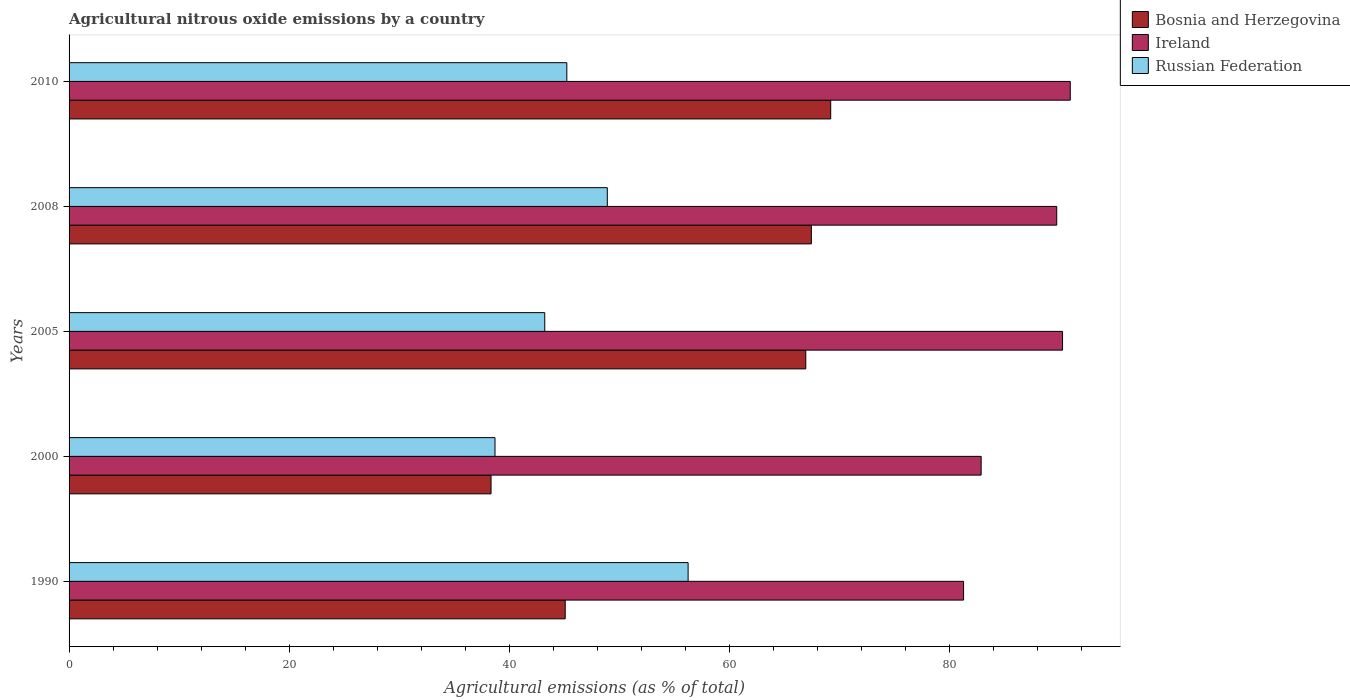How many different coloured bars are there?
Provide a succinct answer. 3. How many groups of bars are there?
Your answer should be very brief. 5. Are the number of bars per tick equal to the number of legend labels?
Provide a short and direct response. Yes. How many bars are there on the 5th tick from the bottom?
Offer a terse response. 3. What is the label of the 3rd group of bars from the top?
Offer a very short reply. 2005. What is the amount of agricultural nitrous oxide emitted in Ireland in 2005?
Provide a short and direct response. 90.31. Across all years, what is the maximum amount of agricultural nitrous oxide emitted in Ireland?
Offer a terse response. 91.01. Across all years, what is the minimum amount of agricultural nitrous oxide emitted in Bosnia and Herzegovina?
Provide a short and direct response. 38.36. What is the total amount of agricultural nitrous oxide emitted in Russian Federation in the graph?
Keep it short and to the point. 232.4. What is the difference between the amount of agricultural nitrous oxide emitted in Russian Federation in 2000 and that in 2005?
Make the answer very short. -4.52. What is the difference between the amount of agricultural nitrous oxide emitted in Russian Federation in 2010 and the amount of agricultural nitrous oxide emitted in Bosnia and Herzegovina in 2005?
Your response must be concise. -21.72. What is the average amount of agricultural nitrous oxide emitted in Ireland per year?
Keep it short and to the point. 87.06. In the year 2005, what is the difference between the amount of agricultural nitrous oxide emitted in Russian Federation and amount of agricultural nitrous oxide emitted in Ireland?
Give a very brief answer. -47.07. In how many years, is the amount of agricultural nitrous oxide emitted in Russian Federation greater than 28 %?
Make the answer very short. 5. What is the ratio of the amount of agricultural nitrous oxide emitted in Russian Federation in 2000 to that in 2010?
Your answer should be compact. 0.86. What is the difference between the highest and the second highest amount of agricultural nitrous oxide emitted in Bosnia and Herzegovina?
Make the answer very short. 1.76. What is the difference between the highest and the lowest amount of agricultural nitrous oxide emitted in Ireland?
Provide a short and direct response. 9.7. In how many years, is the amount of agricultural nitrous oxide emitted in Bosnia and Herzegovina greater than the average amount of agricultural nitrous oxide emitted in Bosnia and Herzegovina taken over all years?
Your answer should be very brief. 3. Is the sum of the amount of agricultural nitrous oxide emitted in Bosnia and Herzegovina in 1990 and 2005 greater than the maximum amount of agricultural nitrous oxide emitted in Ireland across all years?
Your answer should be compact. Yes. What does the 2nd bar from the top in 2005 represents?
Your answer should be very brief. Ireland. What does the 2nd bar from the bottom in 2008 represents?
Your answer should be very brief. Ireland. Is it the case that in every year, the sum of the amount of agricultural nitrous oxide emitted in Ireland and amount of agricultural nitrous oxide emitted in Bosnia and Herzegovina is greater than the amount of agricultural nitrous oxide emitted in Russian Federation?
Your response must be concise. Yes. How many bars are there?
Provide a succinct answer. 15. Are all the bars in the graph horizontal?
Keep it short and to the point. Yes. How many years are there in the graph?
Make the answer very short. 5. Are the values on the major ticks of X-axis written in scientific E-notation?
Ensure brevity in your answer.  No. Does the graph contain any zero values?
Offer a very short reply. No. Where does the legend appear in the graph?
Ensure brevity in your answer.  Top right. What is the title of the graph?
Provide a short and direct response. Agricultural nitrous oxide emissions by a country. Does "Congo (Democratic)" appear as one of the legend labels in the graph?
Ensure brevity in your answer.  No. What is the label or title of the X-axis?
Make the answer very short. Agricultural emissions (as % of total). What is the Agricultural emissions (as % of total) of Bosnia and Herzegovina in 1990?
Give a very brief answer. 45.1. What is the Agricultural emissions (as % of total) in Ireland in 1990?
Provide a short and direct response. 81.31. What is the Agricultural emissions (as % of total) in Russian Federation in 1990?
Give a very brief answer. 56.27. What is the Agricultural emissions (as % of total) in Bosnia and Herzegovina in 2000?
Provide a succinct answer. 38.36. What is the Agricultural emissions (as % of total) in Ireland in 2000?
Give a very brief answer. 82.91. What is the Agricultural emissions (as % of total) of Russian Federation in 2000?
Give a very brief answer. 38.72. What is the Agricultural emissions (as % of total) of Bosnia and Herzegovina in 2005?
Give a very brief answer. 66.97. What is the Agricultural emissions (as % of total) in Ireland in 2005?
Your answer should be very brief. 90.31. What is the Agricultural emissions (as % of total) of Russian Federation in 2005?
Keep it short and to the point. 43.24. What is the Agricultural emissions (as % of total) in Bosnia and Herzegovina in 2008?
Your answer should be very brief. 67.47. What is the Agricultural emissions (as % of total) in Ireland in 2008?
Offer a very short reply. 89.78. What is the Agricultural emissions (as % of total) of Russian Federation in 2008?
Offer a very short reply. 48.93. What is the Agricultural emissions (as % of total) of Bosnia and Herzegovina in 2010?
Your answer should be very brief. 69.23. What is the Agricultural emissions (as % of total) in Ireland in 2010?
Your response must be concise. 91.01. What is the Agricultural emissions (as % of total) of Russian Federation in 2010?
Give a very brief answer. 45.25. Across all years, what is the maximum Agricultural emissions (as % of total) of Bosnia and Herzegovina?
Give a very brief answer. 69.23. Across all years, what is the maximum Agricultural emissions (as % of total) in Ireland?
Provide a short and direct response. 91.01. Across all years, what is the maximum Agricultural emissions (as % of total) of Russian Federation?
Give a very brief answer. 56.27. Across all years, what is the minimum Agricultural emissions (as % of total) in Bosnia and Herzegovina?
Your response must be concise. 38.36. Across all years, what is the minimum Agricultural emissions (as % of total) of Ireland?
Offer a terse response. 81.31. Across all years, what is the minimum Agricultural emissions (as % of total) of Russian Federation?
Your answer should be very brief. 38.72. What is the total Agricultural emissions (as % of total) of Bosnia and Herzegovina in the graph?
Provide a short and direct response. 287.13. What is the total Agricultural emissions (as % of total) of Ireland in the graph?
Keep it short and to the point. 435.31. What is the total Agricultural emissions (as % of total) of Russian Federation in the graph?
Your response must be concise. 232.4. What is the difference between the Agricultural emissions (as % of total) in Bosnia and Herzegovina in 1990 and that in 2000?
Provide a short and direct response. 6.74. What is the difference between the Agricultural emissions (as % of total) in Ireland in 1990 and that in 2000?
Make the answer very short. -1.6. What is the difference between the Agricultural emissions (as % of total) of Russian Federation in 1990 and that in 2000?
Offer a very short reply. 17.55. What is the difference between the Agricultural emissions (as % of total) in Bosnia and Herzegovina in 1990 and that in 2005?
Your answer should be very brief. -21.87. What is the difference between the Agricultural emissions (as % of total) in Ireland in 1990 and that in 2005?
Offer a terse response. -9. What is the difference between the Agricultural emissions (as % of total) of Russian Federation in 1990 and that in 2005?
Offer a terse response. 13.03. What is the difference between the Agricultural emissions (as % of total) in Bosnia and Herzegovina in 1990 and that in 2008?
Keep it short and to the point. -22.37. What is the difference between the Agricultural emissions (as % of total) of Ireland in 1990 and that in 2008?
Give a very brief answer. -8.47. What is the difference between the Agricultural emissions (as % of total) of Russian Federation in 1990 and that in 2008?
Ensure brevity in your answer.  7.34. What is the difference between the Agricultural emissions (as % of total) of Bosnia and Herzegovina in 1990 and that in 2010?
Your answer should be very brief. -24.13. What is the difference between the Agricultural emissions (as % of total) in Ireland in 1990 and that in 2010?
Provide a succinct answer. -9.7. What is the difference between the Agricultural emissions (as % of total) of Russian Federation in 1990 and that in 2010?
Provide a succinct answer. 11.02. What is the difference between the Agricultural emissions (as % of total) in Bosnia and Herzegovina in 2000 and that in 2005?
Make the answer very short. -28.61. What is the difference between the Agricultural emissions (as % of total) in Ireland in 2000 and that in 2005?
Ensure brevity in your answer.  -7.4. What is the difference between the Agricultural emissions (as % of total) of Russian Federation in 2000 and that in 2005?
Provide a short and direct response. -4.52. What is the difference between the Agricultural emissions (as % of total) of Bosnia and Herzegovina in 2000 and that in 2008?
Provide a short and direct response. -29.12. What is the difference between the Agricultural emissions (as % of total) of Ireland in 2000 and that in 2008?
Your answer should be compact. -6.87. What is the difference between the Agricultural emissions (as % of total) in Russian Federation in 2000 and that in 2008?
Give a very brief answer. -10.21. What is the difference between the Agricultural emissions (as % of total) of Bosnia and Herzegovina in 2000 and that in 2010?
Your answer should be very brief. -30.88. What is the difference between the Agricultural emissions (as % of total) in Ireland in 2000 and that in 2010?
Offer a terse response. -8.1. What is the difference between the Agricultural emissions (as % of total) of Russian Federation in 2000 and that in 2010?
Your answer should be compact. -6.53. What is the difference between the Agricultural emissions (as % of total) of Bosnia and Herzegovina in 2005 and that in 2008?
Offer a terse response. -0.51. What is the difference between the Agricultural emissions (as % of total) in Ireland in 2005 and that in 2008?
Provide a short and direct response. 0.53. What is the difference between the Agricultural emissions (as % of total) in Russian Federation in 2005 and that in 2008?
Provide a succinct answer. -5.69. What is the difference between the Agricultural emissions (as % of total) of Bosnia and Herzegovina in 2005 and that in 2010?
Your answer should be compact. -2.27. What is the difference between the Agricultural emissions (as % of total) in Ireland in 2005 and that in 2010?
Ensure brevity in your answer.  -0.7. What is the difference between the Agricultural emissions (as % of total) in Russian Federation in 2005 and that in 2010?
Give a very brief answer. -2.01. What is the difference between the Agricultural emissions (as % of total) of Bosnia and Herzegovina in 2008 and that in 2010?
Provide a succinct answer. -1.76. What is the difference between the Agricultural emissions (as % of total) of Ireland in 2008 and that in 2010?
Offer a terse response. -1.23. What is the difference between the Agricultural emissions (as % of total) of Russian Federation in 2008 and that in 2010?
Keep it short and to the point. 3.68. What is the difference between the Agricultural emissions (as % of total) of Bosnia and Herzegovina in 1990 and the Agricultural emissions (as % of total) of Ireland in 2000?
Your response must be concise. -37.81. What is the difference between the Agricultural emissions (as % of total) of Bosnia and Herzegovina in 1990 and the Agricultural emissions (as % of total) of Russian Federation in 2000?
Offer a very short reply. 6.38. What is the difference between the Agricultural emissions (as % of total) of Ireland in 1990 and the Agricultural emissions (as % of total) of Russian Federation in 2000?
Provide a succinct answer. 42.59. What is the difference between the Agricultural emissions (as % of total) of Bosnia and Herzegovina in 1990 and the Agricultural emissions (as % of total) of Ireland in 2005?
Provide a succinct answer. -45.21. What is the difference between the Agricultural emissions (as % of total) in Bosnia and Herzegovina in 1990 and the Agricultural emissions (as % of total) in Russian Federation in 2005?
Your answer should be compact. 1.86. What is the difference between the Agricultural emissions (as % of total) in Ireland in 1990 and the Agricultural emissions (as % of total) in Russian Federation in 2005?
Provide a succinct answer. 38.07. What is the difference between the Agricultural emissions (as % of total) of Bosnia and Herzegovina in 1990 and the Agricultural emissions (as % of total) of Ireland in 2008?
Give a very brief answer. -44.68. What is the difference between the Agricultural emissions (as % of total) of Bosnia and Herzegovina in 1990 and the Agricultural emissions (as % of total) of Russian Federation in 2008?
Provide a succinct answer. -3.83. What is the difference between the Agricultural emissions (as % of total) of Ireland in 1990 and the Agricultural emissions (as % of total) of Russian Federation in 2008?
Offer a terse response. 32.38. What is the difference between the Agricultural emissions (as % of total) in Bosnia and Herzegovina in 1990 and the Agricultural emissions (as % of total) in Ireland in 2010?
Your answer should be compact. -45.91. What is the difference between the Agricultural emissions (as % of total) in Bosnia and Herzegovina in 1990 and the Agricultural emissions (as % of total) in Russian Federation in 2010?
Your answer should be compact. -0.15. What is the difference between the Agricultural emissions (as % of total) of Ireland in 1990 and the Agricultural emissions (as % of total) of Russian Federation in 2010?
Your response must be concise. 36.07. What is the difference between the Agricultural emissions (as % of total) in Bosnia and Herzegovina in 2000 and the Agricultural emissions (as % of total) in Ireland in 2005?
Offer a very short reply. -51.95. What is the difference between the Agricultural emissions (as % of total) of Bosnia and Herzegovina in 2000 and the Agricultural emissions (as % of total) of Russian Federation in 2005?
Your answer should be very brief. -4.88. What is the difference between the Agricultural emissions (as % of total) of Ireland in 2000 and the Agricultural emissions (as % of total) of Russian Federation in 2005?
Offer a terse response. 39.67. What is the difference between the Agricultural emissions (as % of total) in Bosnia and Herzegovina in 2000 and the Agricultural emissions (as % of total) in Ireland in 2008?
Your response must be concise. -51.42. What is the difference between the Agricultural emissions (as % of total) of Bosnia and Herzegovina in 2000 and the Agricultural emissions (as % of total) of Russian Federation in 2008?
Offer a terse response. -10.57. What is the difference between the Agricultural emissions (as % of total) of Ireland in 2000 and the Agricultural emissions (as % of total) of Russian Federation in 2008?
Provide a succinct answer. 33.98. What is the difference between the Agricultural emissions (as % of total) of Bosnia and Herzegovina in 2000 and the Agricultural emissions (as % of total) of Ireland in 2010?
Provide a short and direct response. -52.65. What is the difference between the Agricultural emissions (as % of total) in Bosnia and Herzegovina in 2000 and the Agricultural emissions (as % of total) in Russian Federation in 2010?
Give a very brief answer. -6.89. What is the difference between the Agricultural emissions (as % of total) in Ireland in 2000 and the Agricultural emissions (as % of total) in Russian Federation in 2010?
Keep it short and to the point. 37.66. What is the difference between the Agricultural emissions (as % of total) in Bosnia and Herzegovina in 2005 and the Agricultural emissions (as % of total) in Ireland in 2008?
Give a very brief answer. -22.81. What is the difference between the Agricultural emissions (as % of total) of Bosnia and Herzegovina in 2005 and the Agricultural emissions (as % of total) of Russian Federation in 2008?
Give a very brief answer. 18.04. What is the difference between the Agricultural emissions (as % of total) in Ireland in 2005 and the Agricultural emissions (as % of total) in Russian Federation in 2008?
Keep it short and to the point. 41.38. What is the difference between the Agricultural emissions (as % of total) in Bosnia and Herzegovina in 2005 and the Agricultural emissions (as % of total) in Ireland in 2010?
Ensure brevity in your answer.  -24.04. What is the difference between the Agricultural emissions (as % of total) of Bosnia and Herzegovina in 2005 and the Agricultural emissions (as % of total) of Russian Federation in 2010?
Provide a short and direct response. 21.72. What is the difference between the Agricultural emissions (as % of total) in Ireland in 2005 and the Agricultural emissions (as % of total) in Russian Federation in 2010?
Keep it short and to the point. 45.06. What is the difference between the Agricultural emissions (as % of total) in Bosnia and Herzegovina in 2008 and the Agricultural emissions (as % of total) in Ireland in 2010?
Your response must be concise. -23.53. What is the difference between the Agricultural emissions (as % of total) of Bosnia and Herzegovina in 2008 and the Agricultural emissions (as % of total) of Russian Federation in 2010?
Provide a succinct answer. 22.23. What is the difference between the Agricultural emissions (as % of total) of Ireland in 2008 and the Agricultural emissions (as % of total) of Russian Federation in 2010?
Provide a short and direct response. 44.53. What is the average Agricultural emissions (as % of total) in Bosnia and Herzegovina per year?
Provide a succinct answer. 57.43. What is the average Agricultural emissions (as % of total) of Ireland per year?
Offer a terse response. 87.06. What is the average Agricultural emissions (as % of total) in Russian Federation per year?
Provide a succinct answer. 46.48. In the year 1990, what is the difference between the Agricultural emissions (as % of total) in Bosnia and Herzegovina and Agricultural emissions (as % of total) in Ireland?
Ensure brevity in your answer.  -36.21. In the year 1990, what is the difference between the Agricultural emissions (as % of total) of Bosnia and Herzegovina and Agricultural emissions (as % of total) of Russian Federation?
Your answer should be compact. -11.17. In the year 1990, what is the difference between the Agricultural emissions (as % of total) in Ireland and Agricultural emissions (as % of total) in Russian Federation?
Your answer should be very brief. 25.04. In the year 2000, what is the difference between the Agricultural emissions (as % of total) of Bosnia and Herzegovina and Agricultural emissions (as % of total) of Ireland?
Make the answer very short. -44.55. In the year 2000, what is the difference between the Agricultural emissions (as % of total) of Bosnia and Herzegovina and Agricultural emissions (as % of total) of Russian Federation?
Make the answer very short. -0.36. In the year 2000, what is the difference between the Agricultural emissions (as % of total) in Ireland and Agricultural emissions (as % of total) in Russian Federation?
Your answer should be very brief. 44.19. In the year 2005, what is the difference between the Agricultural emissions (as % of total) in Bosnia and Herzegovina and Agricultural emissions (as % of total) in Ireland?
Your response must be concise. -23.34. In the year 2005, what is the difference between the Agricultural emissions (as % of total) of Bosnia and Herzegovina and Agricultural emissions (as % of total) of Russian Federation?
Offer a terse response. 23.73. In the year 2005, what is the difference between the Agricultural emissions (as % of total) in Ireland and Agricultural emissions (as % of total) in Russian Federation?
Ensure brevity in your answer.  47.07. In the year 2008, what is the difference between the Agricultural emissions (as % of total) of Bosnia and Herzegovina and Agricultural emissions (as % of total) of Ireland?
Provide a short and direct response. -22.31. In the year 2008, what is the difference between the Agricultural emissions (as % of total) of Bosnia and Herzegovina and Agricultural emissions (as % of total) of Russian Federation?
Give a very brief answer. 18.55. In the year 2008, what is the difference between the Agricultural emissions (as % of total) of Ireland and Agricultural emissions (as % of total) of Russian Federation?
Ensure brevity in your answer.  40.85. In the year 2010, what is the difference between the Agricultural emissions (as % of total) in Bosnia and Herzegovina and Agricultural emissions (as % of total) in Ireland?
Offer a very short reply. -21.78. In the year 2010, what is the difference between the Agricultural emissions (as % of total) in Bosnia and Herzegovina and Agricultural emissions (as % of total) in Russian Federation?
Offer a very short reply. 23.99. In the year 2010, what is the difference between the Agricultural emissions (as % of total) in Ireland and Agricultural emissions (as % of total) in Russian Federation?
Your answer should be very brief. 45.76. What is the ratio of the Agricultural emissions (as % of total) in Bosnia and Herzegovina in 1990 to that in 2000?
Your answer should be compact. 1.18. What is the ratio of the Agricultural emissions (as % of total) of Ireland in 1990 to that in 2000?
Offer a terse response. 0.98. What is the ratio of the Agricultural emissions (as % of total) in Russian Federation in 1990 to that in 2000?
Offer a terse response. 1.45. What is the ratio of the Agricultural emissions (as % of total) in Bosnia and Herzegovina in 1990 to that in 2005?
Make the answer very short. 0.67. What is the ratio of the Agricultural emissions (as % of total) in Ireland in 1990 to that in 2005?
Provide a short and direct response. 0.9. What is the ratio of the Agricultural emissions (as % of total) of Russian Federation in 1990 to that in 2005?
Provide a succinct answer. 1.3. What is the ratio of the Agricultural emissions (as % of total) of Bosnia and Herzegovina in 1990 to that in 2008?
Provide a succinct answer. 0.67. What is the ratio of the Agricultural emissions (as % of total) in Ireland in 1990 to that in 2008?
Keep it short and to the point. 0.91. What is the ratio of the Agricultural emissions (as % of total) in Russian Federation in 1990 to that in 2008?
Your answer should be very brief. 1.15. What is the ratio of the Agricultural emissions (as % of total) of Bosnia and Herzegovina in 1990 to that in 2010?
Your answer should be very brief. 0.65. What is the ratio of the Agricultural emissions (as % of total) of Ireland in 1990 to that in 2010?
Ensure brevity in your answer.  0.89. What is the ratio of the Agricultural emissions (as % of total) of Russian Federation in 1990 to that in 2010?
Your response must be concise. 1.24. What is the ratio of the Agricultural emissions (as % of total) in Bosnia and Herzegovina in 2000 to that in 2005?
Your answer should be very brief. 0.57. What is the ratio of the Agricultural emissions (as % of total) of Ireland in 2000 to that in 2005?
Provide a succinct answer. 0.92. What is the ratio of the Agricultural emissions (as % of total) of Russian Federation in 2000 to that in 2005?
Your answer should be very brief. 0.9. What is the ratio of the Agricultural emissions (as % of total) of Bosnia and Herzegovina in 2000 to that in 2008?
Give a very brief answer. 0.57. What is the ratio of the Agricultural emissions (as % of total) of Ireland in 2000 to that in 2008?
Provide a succinct answer. 0.92. What is the ratio of the Agricultural emissions (as % of total) of Russian Federation in 2000 to that in 2008?
Provide a short and direct response. 0.79. What is the ratio of the Agricultural emissions (as % of total) in Bosnia and Herzegovina in 2000 to that in 2010?
Ensure brevity in your answer.  0.55. What is the ratio of the Agricultural emissions (as % of total) in Ireland in 2000 to that in 2010?
Offer a very short reply. 0.91. What is the ratio of the Agricultural emissions (as % of total) in Russian Federation in 2000 to that in 2010?
Provide a succinct answer. 0.86. What is the ratio of the Agricultural emissions (as % of total) of Ireland in 2005 to that in 2008?
Keep it short and to the point. 1.01. What is the ratio of the Agricultural emissions (as % of total) of Russian Federation in 2005 to that in 2008?
Offer a very short reply. 0.88. What is the ratio of the Agricultural emissions (as % of total) of Bosnia and Herzegovina in 2005 to that in 2010?
Give a very brief answer. 0.97. What is the ratio of the Agricultural emissions (as % of total) in Russian Federation in 2005 to that in 2010?
Provide a short and direct response. 0.96. What is the ratio of the Agricultural emissions (as % of total) of Bosnia and Herzegovina in 2008 to that in 2010?
Your answer should be very brief. 0.97. What is the ratio of the Agricultural emissions (as % of total) of Ireland in 2008 to that in 2010?
Provide a succinct answer. 0.99. What is the ratio of the Agricultural emissions (as % of total) of Russian Federation in 2008 to that in 2010?
Keep it short and to the point. 1.08. What is the difference between the highest and the second highest Agricultural emissions (as % of total) in Bosnia and Herzegovina?
Keep it short and to the point. 1.76. What is the difference between the highest and the second highest Agricultural emissions (as % of total) in Ireland?
Provide a succinct answer. 0.7. What is the difference between the highest and the second highest Agricultural emissions (as % of total) in Russian Federation?
Provide a short and direct response. 7.34. What is the difference between the highest and the lowest Agricultural emissions (as % of total) of Bosnia and Herzegovina?
Provide a succinct answer. 30.88. What is the difference between the highest and the lowest Agricultural emissions (as % of total) in Ireland?
Your answer should be compact. 9.7. What is the difference between the highest and the lowest Agricultural emissions (as % of total) in Russian Federation?
Make the answer very short. 17.55. 